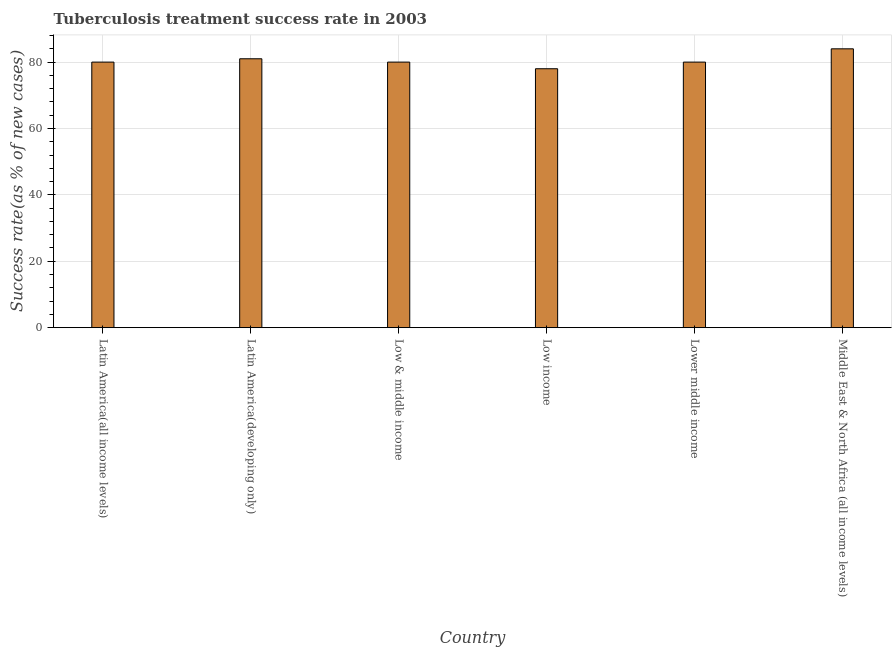Does the graph contain grids?
Provide a succinct answer. Yes. What is the title of the graph?
Keep it short and to the point. Tuberculosis treatment success rate in 2003. What is the label or title of the Y-axis?
Make the answer very short. Success rate(as % of new cases). Across all countries, what is the minimum tuberculosis treatment success rate?
Provide a short and direct response. 78. In which country was the tuberculosis treatment success rate maximum?
Your response must be concise. Middle East & North Africa (all income levels). What is the sum of the tuberculosis treatment success rate?
Give a very brief answer. 483. What is the difference between the tuberculosis treatment success rate in Latin America(all income levels) and Middle East & North Africa (all income levels)?
Your answer should be compact. -4. Is the difference between the tuberculosis treatment success rate in Latin America(developing only) and Lower middle income greater than the difference between any two countries?
Ensure brevity in your answer.  No. What is the difference between the highest and the lowest tuberculosis treatment success rate?
Provide a short and direct response. 6. Are all the bars in the graph horizontal?
Provide a succinct answer. No. What is the difference between two consecutive major ticks on the Y-axis?
Provide a succinct answer. 20. Are the values on the major ticks of Y-axis written in scientific E-notation?
Keep it short and to the point. No. What is the Success rate(as % of new cases) in Low income?
Your response must be concise. 78. What is the difference between the Success rate(as % of new cases) in Latin America(all income levels) and Latin America(developing only)?
Offer a very short reply. -1. What is the difference between the Success rate(as % of new cases) in Latin America(all income levels) and Low & middle income?
Your answer should be very brief. 0. What is the difference between the Success rate(as % of new cases) in Latin America(all income levels) and Low income?
Offer a very short reply. 2. What is the difference between the Success rate(as % of new cases) in Latin America(all income levels) and Lower middle income?
Provide a short and direct response. 0. What is the difference between the Success rate(as % of new cases) in Latin America(developing only) and Low income?
Your response must be concise. 3. What is the difference between the Success rate(as % of new cases) in Latin America(developing only) and Lower middle income?
Keep it short and to the point. 1. What is the difference between the Success rate(as % of new cases) in Latin America(developing only) and Middle East & North Africa (all income levels)?
Your answer should be compact. -3. What is the difference between the Success rate(as % of new cases) in Low & middle income and Low income?
Provide a short and direct response. 2. What is the difference between the Success rate(as % of new cases) in Low & middle income and Lower middle income?
Your response must be concise. 0. What is the difference between the Success rate(as % of new cases) in Low & middle income and Middle East & North Africa (all income levels)?
Your answer should be very brief. -4. What is the ratio of the Success rate(as % of new cases) in Latin America(all income levels) to that in Low & middle income?
Make the answer very short. 1. What is the ratio of the Success rate(as % of new cases) in Latin America(all income levels) to that in Middle East & North Africa (all income levels)?
Provide a short and direct response. 0.95. What is the ratio of the Success rate(as % of new cases) in Latin America(developing only) to that in Low income?
Make the answer very short. 1.04. What is the ratio of the Success rate(as % of new cases) in Latin America(developing only) to that in Lower middle income?
Provide a short and direct response. 1.01. What is the ratio of the Success rate(as % of new cases) in Latin America(developing only) to that in Middle East & North Africa (all income levels)?
Ensure brevity in your answer.  0.96. What is the ratio of the Success rate(as % of new cases) in Low & middle income to that in Middle East & North Africa (all income levels)?
Your answer should be very brief. 0.95. What is the ratio of the Success rate(as % of new cases) in Low income to that in Lower middle income?
Make the answer very short. 0.97. What is the ratio of the Success rate(as % of new cases) in Low income to that in Middle East & North Africa (all income levels)?
Offer a terse response. 0.93. 